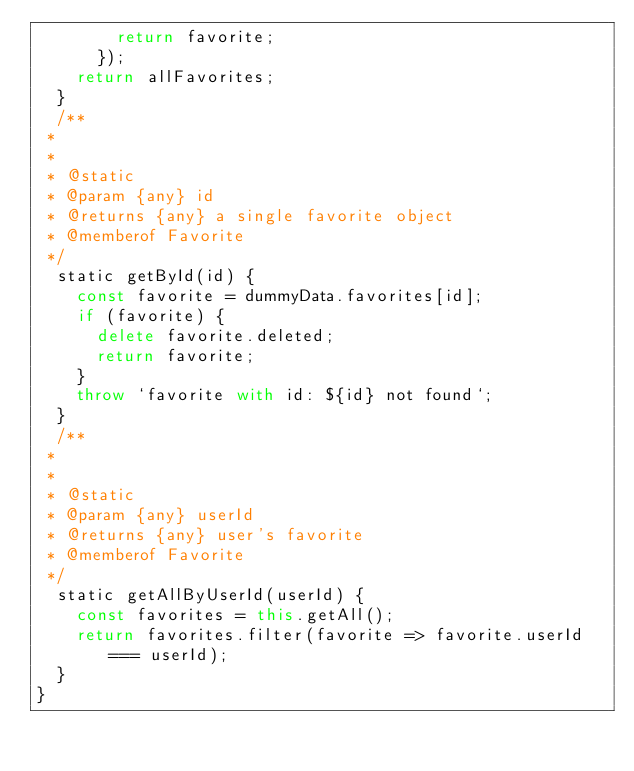Convert code to text. <code><loc_0><loc_0><loc_500><loc_500><_JavaScript_>        return favorite;
      });
    return allFavorites;
  }
  /**
 *
 *
 * @static
 * @param {any} id
 * @returns {any} a single favorite object
 * @memberof Favorite
 */
  static getById(id) {
    const favorite = dummyData.favorites[id];
    if (favorite) {
      delete favorite.deleted;
      return favorite;
    }
    throw `favorite with id: ${id} not found`;
  }
  /**
 *
 *
 * @static
 * @param {any} userId
 * @returns {any} user's favorite
 * @memberof Favorite
 */
  static getAllByUserId(userId) {
    const favorites = this.getAll();
    return favorites.filter(favorite => favorite.userId === userId);
  }
}

</code> 